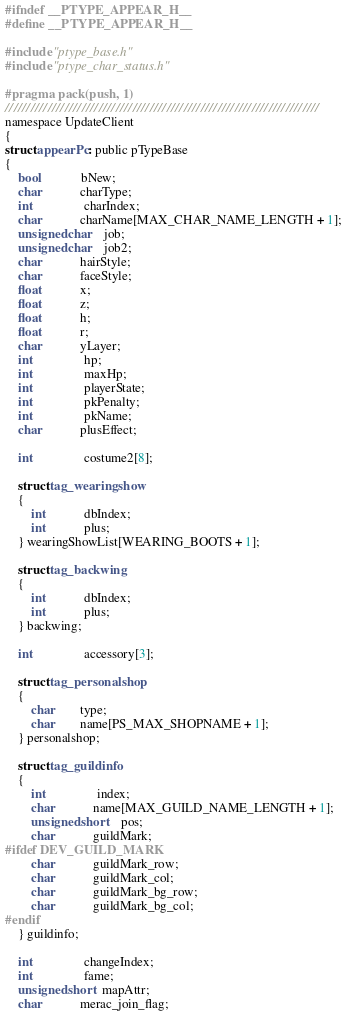Convert code to text. <code><loc_0><loc_0><loc_500><loc_500><_C_>#ifndef __PTYPE_APPEAR_H__
#define __PTYPE_APPEAR_H__

#include "ptype_base.h"
#include "ptype_char_status.h"

#pragma pack(push, 1)
//////////////////////////////////////////////////////////////////////////
namespace UpdateClient
{
struct appearPc : public pTypeBase
{
	bool			bNew;
	char			charType;
	int				charIndex;
	char			charName[MAX_CHAR_NAME_LENGTH + 1];
	unsigned char	job;
	unsigned char	job2;
	char			hairStyle;
	char			faceStyle;
	float			x;
	float			z;
	float			h;
	float			r;
	char			yLayer;
	int				hp;
	int				maxHp;
	int				playerState;
	int				pkPenalty;
	int				pkName;
	char			plusEffect;

	int				costume2[8];

	struct tag_wearingshow
	{
		int			dbIndex;
		int			plus;
	} wearingShowList[WEARING_BOOTS + 1];

	struct tag_backwing
	{
		int			dbIndex;
		int			plus;
	} backwing;

	int				accessory[3];

	struct tag_personalshop
	{
		char		type;
		char		name[PS_MAX_SHOPNAME + 1];
	} personalshop;

	struct tag_guildinfo
	{
		int				index;
		char			name[MAX_GUILD_NAME_LENGTH + 1];
		unsigned short	pos;
		char			guildMark;
#ifdef DEV_GUILD_MARK
		char			guildMark_row;
		char			guildMark_col;
		char			guildMark_bg_row;
		char			guildMark_bg_col;
#endif
	} guildinfo;

	int				changeIndex;
	int				fame;
	unsigned short  mapAttr;
	char			merac_join_flag;</code> 